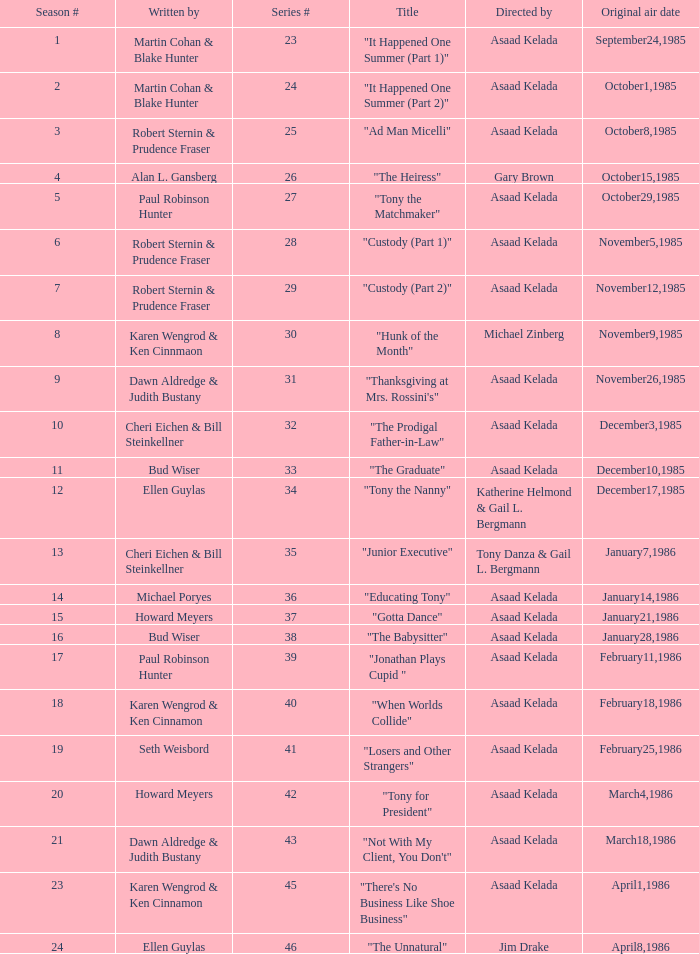What season features writer Michael Poryes? 14.0. 